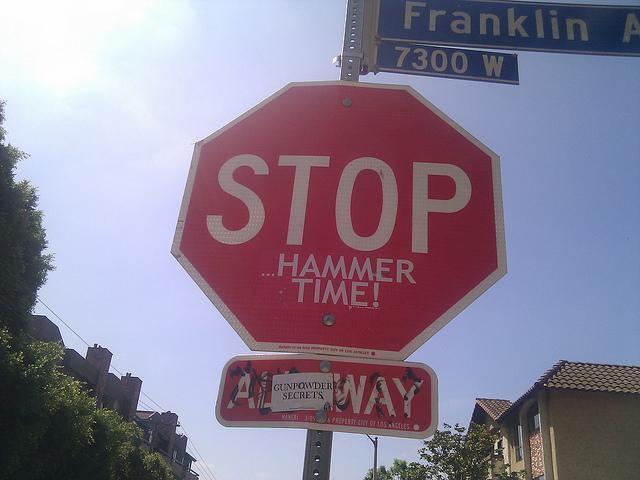How many people on any type of bike are facing the camera?
Give a very brief answer. 0. 